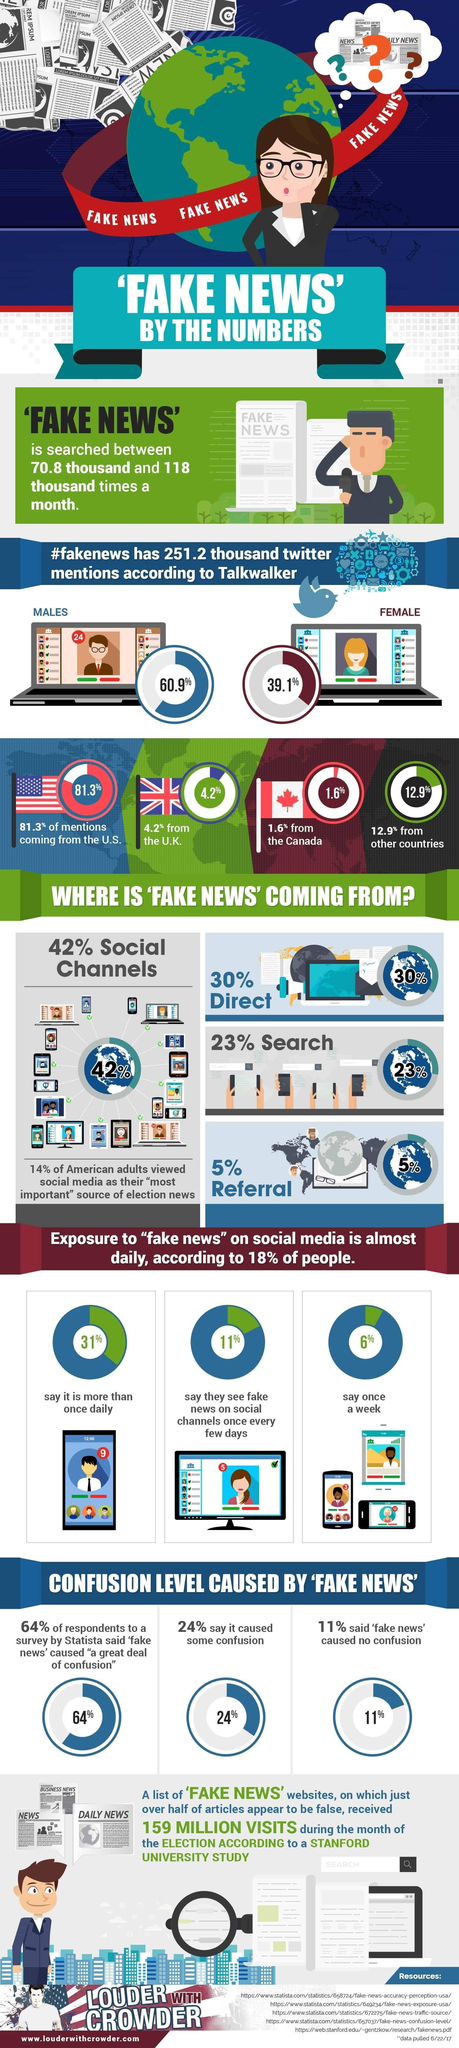List a handful of essential elements in this visual. According to the survey, 42% of the participants reported viewing fake news almost daily or more than once a day. According to the data, 64% of viewers did not feel confused while reading fake news, while 24% of viewers felt somewhat confused and 11% of viewers felt very confused. The United States, the United Kingdom, and Canada have generated 87.1% of fake news. 